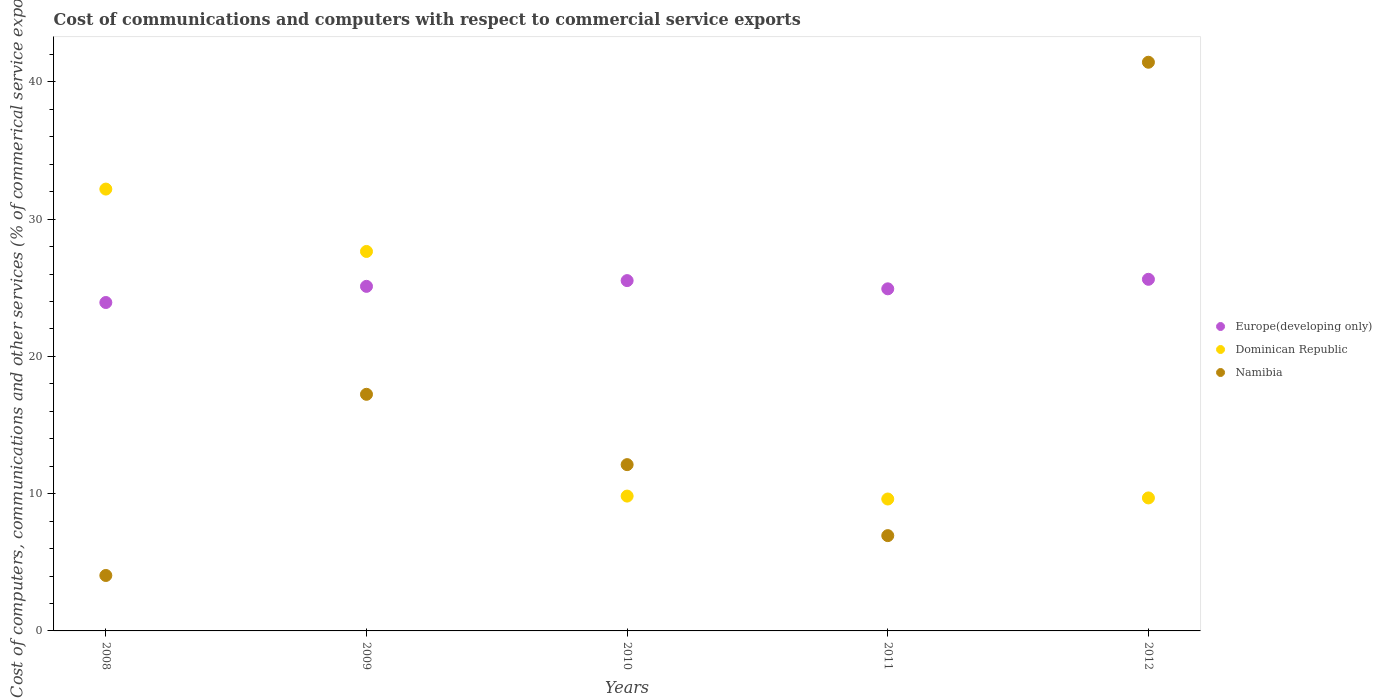Is the number of dotlines equal to the number of legend labels?
Your response must be concise. Yes. What is the cost of communications and computers in Dominican Republic in 2010?
Offer a terse response. 9.82. Across all years, what is the maximum cost of communications and computers in Europe(developing only)?
Your answer should be compact. 25.62. Across all years, what is the minimum cost of communications and computers in Namibia?
Give a very brief answer. 4.04. In which year was the cost of communications and computers in Europe(developing only) minimum?
Your answer should be very brief. 2008. What is the total cost of communications and computers in Dominican Republic in the graph?
Offer a very short reply. 88.97. What is the difference between the cost of communications and computers in Europe(developing only) in 2009 and that in 2010?
Your response must be concise. -0.42. What is the difference between the cost of communications and computers in Europe(developing only) in 2010 and the cost of communications and computers in Namibia in 2009?
Make the answer very short. 8.28. What is the average cost of communications and computers in Namibia per year?
Your answer should be very brief. 16.35. In the year 2011, what is the difference between the cost of communications and computers in Europe(developing only) and cost of communications and computers in Namibia?
Provide a short and direct response. 17.98. What is the ratio of the cost of communications and computers in Dominican Republic in 2009 to that in 2010?
Your response must be concise. 2.81. What is the difference between the highest and the second highest cost of communications and computers in Europe(developing only)?
Your answer should be compact. 0.1. What is the difference between the highest and the lowest cost of communications and computers in Europe(developing only)?
Your answer should be compact. 1.69. In how many years, is the cost of communications and computers in Dominican Republic greater than the average cost of communications and computers in Dominican Republic taken over all years?
Offer a very short reply. 2. Is the sum of the cost of communications and computers in Europe(developing only) in 2008 and 2011 greater than the maximum cost of communications and computers in Dominican Republic across all years?
Ensure brevity in your answer.  Yes. Is it the case that in every year, the sum of the cost of communications and computers in Dominican Republic and cost of communications and computers in Europe(developing only)  is greater than the cost of communications and computers in Namibia?
Your response must be concise. No. Is the cost of communications and computers in Dominican Republic strictly greater than the cost of communications and computers in Europe(developing only) over the years?
Offer a terse response. No. Is the cost of communications and computers in Europe(developing only) strictly less than the cost of communications and computers in Dominican Republic over the years?
Keep it short and to the point. No. How many years are there in the graph?
Give a very brief answer. 5. Are the values on the major ticks of Y-axis written in scientific E-notation?
Provide a short and direct response. No. Does the graph contain grids?
Provide a short and direct response. No. How many legend labels are there?
Your answer should be very brief. 3. What is the title of the graph?
Provide a short and direct response. Cost of communications and computers with respect to commercial service exports. Does "French Polynesia" appear as one of the legend labels in the graph?
Offer a very short reply. No. What is the label or title of the X-axis?
Make the answer very short. Years. What is the label or title of the Y-axis?
Provide a short and direct response. Cost of computers, communications and other services (% of commerical service exports). What is the Cost of computers, communications and other services (% of commerical service exports) in Europe(developing only) in 2008?
Your answer should be compact. 23.93. What is the Cost of computers, communications and other services (% of commerical service exports) in Dominican Republic in 2008?
Ensure brevity in your answer.  32.19. What is the Cost of computers, communications and other services (% of commerical service exports) of Namibia in 2008?
Provide a succinct answer. 4.04. What is the Cost of computers, communications and other services (% of commerical service exports) in Europe(developing only) in 2009?
Provide a short and direct response. 25.11. What is the Cost of computers, communications and other services (% of commerical service exports) of Dominican Republic in 2009?
Your answer should be compact. 27.65. What is the Cost of computers, communications and other services (% of commerical service exports) of Namibia in 2009?
Your response must be concise. 17.24. What is the Cost of computers, communications and other services (% of commerical service exports) in Europe(developing only) in 2010?
Your answer should be compact. 25.52. What is the Cost of computers, communications and other services (% of commerical service exports) of Dominican Republic in 2010?
Offer a very short reply. 9.82. What is the Cost of computers, communications and other services (% of commerical service exports) of Namibia in 2010?
Provide a succinct answer. 12.12. What is the Cost of computers, communications and other services (% of commerical service exports) in Europe(developing only) in 2011?
Your response must be concise. 24.93. What is the Cost of computers, communications and other services (% of commerical service exports) in Dominican Republic in 2011?
Provide a succinct answer. 9.61. What is the Cost of computers, communications and other services (% of commerical service exports) of Namibia in 2011?
Your answer should be compact. 6.94. What is the Cost of computers, communications and other services (% of commerical service exports) in Europe(developing only) in 2012?
Ensure brevity in your answer.  25.62. What is the Cost of computers, communications and other services (% of commerical service exports) in Dominican Republic in 2012?
Ensure brevity in your answer.  9.69. What is the Cost of computers, communications and other services (% of commerical service exports) of Namibia in 2012?
Offer a terse response. 41.43. Across all years, what is the maximum Cost of computers, communications and other services (% of commerical service exports) in Europe(developing only)?
Offer a very short reply. 25.62. Across all years, what is the maximum Cost of computers, communications and other services (% of commerical service exports) of Dominican Republic?
Ensure brevity in your answer.  32.19. Across all years, what is the maximum Cost of computers, communications and other services (% of commerical service exports) of Namibia?
Make the answer very short. 41.43. Across all years, what is the minimum Cost of computers, communications and other services (% of commerical service exports) of Europe(developing only)?
Make the answer very short. 23.93. Across all years, what is the minimum Cost of computers, communications and other services (% of commerical service exports) in Dominican Republic?
Offer a very short reply. 9.61. Across all years, what is the minimum Cost of computers, communications and other services (% of commerical service exports) of Namibia?
Ensure brevity in your answer.  4.04. What is the total Cost of computers, communications and other services (% of commerical service exports) of Europe(developing only) in the graph?
Provide a short and direct response. 125.1. What is the total Cost of computers, communications and other services (% of commerical service exports) in Dominican Republic in the graph?
Offer a very short reply. 88.97. What is the total Cost of computers, communications and other services (% of commerical service exports) in Namibia in the graph?
Ensure brevity in your answer.  81.77. What is the difference between the Cost of computers, communications and other services (% of commerical service exports) of Europe(developing only) in 2008 and that in 2009?
Your response must be concise. -1.18. What is the difference between the Cost of computers, communications and other services (% of commerical service exports) in Dominican Republic in 2008 and that in 2009?
Keep it short and to the point. 4.54. What is the difference between the Cost of computers, communications and other services (% of commerical service exports) of Namibia in 2008 and that in 2009?
Offer a very short reply. -13.2. What is the difference between the Cost of computers, communications and other services (% of commerical service exports) of Europe(developing only) in 2008 and that in 2010?
Keep it short and to the point. -1.6. What is the difference between the Cost of computers, communications and other services (% of commerical service exports) in Dominican Republic in 2008 and that in 2010?
Offer a very short reply. 22.37. What is the difference between the Cost of computers, communications and other services (% of commerical service exports) of Namibia in 2008 and that in 2010?
Your response must be concise. -8.08. What is the difference between the Cost of computers, communications and other services (% of commerical service exports) in Europe(developing only) in 2008 and that in 2011?
Ensure brevity in your answer.  -1. What is the difference between the Cost of computers, communications and other services (% of commerical service exports) of Dominican Republic in 2008 and that in 2011?
Keep it short and to the point. 22.58. What is the difference between the Cost of computers, communications and other services (% of commerical service exports) in Namibia in 2008 and that in 2011?
Your answer should be very brief. -2.9. What is the difference between the Cost of computers, communications and other services (% of commerical service exports) in Europe(developing only) in 2008 and that in 2012?
Your response must be concise. -1.69. What is the difference between the Cost of computers, communications and other services (% of commerical service exports) of Dominican Republic in 2008 and that in 2012?
Provide a succinct answer. 22.5. What is the difference between the Cost of computers, communications and other services (% of commerical service exports) in Namibia in 2008 and that in 2012?
Ensure brevity in your answer.  -37.4. What is the difference between the Cost of computers, communications and other services (% of commerical service exports) in Europe(developing only) in 2009 and that in 2010?
Provide a succinct answer. -0.42. What is the difference between the Cost of computers, communications and other services (% of commerical service exports) of Dominican Republic in 2009 and that in 2010?
Your response must be concise. 17.82. What is the difference between the Cost of computers, communications and other services (% of commerical service exports) in Namibia in 2009 and that in 2010?
Keep it short and to the point. 5.12. What is the difference between the Cost of computers, communications and other services (% of commerical service exports) of Europe(developing only) in 2009 and that in 2011?
Offer a terse response. 0.18. What is the difference between the Cost of computers, communications and other services (% of commerical service exports) in Dominican Republic in 2009 and that in 2011?
Provide a succinct answer. 18.04. What is the difference between the Cost of computers, communications and other services (% of commerical service exports) in Namibia in 2009 and that in 2011?
Make the answer very short. 10.3. What is the difference between the Cost of computers, communications and other services (% of commerical service exports) in Europe(developing only) in 2009 and that in 2012?
Your answer should be very brief. -0.51. What is the difference between the Cost of computers, communications and other services (% of commerical service exports) in Dominican Republic in 2009 and that in 2012?
Provide a succinct answer. 17.96. What is the difference between the Cost of computers, communications and other services (% of commerical service exports) in Namibia in 2009 and that in 2012?
Your response must be concise. -24.19. What is the difference between the Cost of computers, communications and other services (% of commerical service exports) in Europe(developing only) in 2010 and that in 2011?
Your response must be concise. 0.6. What is the difference between the Cost of computers, communications and other services (% of commerical service exports) in Dominican Republic in 2010 and that in 2011?
Give a very brief answer. 0.21. What is the difference between the Cost of computers, communications and other services (% of commerical service exports) in Namibia in 2010 and that in 2011?
Provide a short and direct response. 5.17. What is the difference between the Cost of computers, communications and other services (% of commerical service exports) of Europe(developing only) in 2010 and that in 2012?
Your answer should be very brief. -0.1. What is the difference between the Cost of computers, communications and other services (% of commerical service exports) in Dominican Republic in 2010 and that in 2012?
Your answer should be very brief. 0.13. What is the difference between the Cost of computers, communications and other services (% of commerical service exports) in Namibia in 2010 and that in 2012?
Make the answer very short. -29.32. What is the difference between the Cost of computers, communications and other services (% of commerical service exports) of Europe(developing only) in 2011 and that in 2012?
Keep it short and to the point. -0.69. What is the difference between the Cost of computers, communications and other services (% of commerical service exports) of Dominican Republic in 2011 and that in 2012?
Provide a succinct answer. -0.08. What is the difference between the Cost of computers, communications and other services (% of commerical service exports) of Namibia in 2011 and that in 2012?
Offer a very short reply. -34.49. What is the difference between the Cost of computers, communications and other services (% of commerical service exports) in Europe(developing only) in 2008 and the Cost of computers, communications and other services (% of commerical service exports) in Dominican Republic in 2009?
Give a very brief answer. -3.72. What is the difference between the Cost of computers, communications and other services (% of commerical service exports) of Europe(developing only) in 2008 and the Cost of computers, communications and other services (% of commerical service exports) of Namibia in 2009?
Keep it short and to the point. 6.69. What is the difference between the Cost of computers, communications and other services (% of commerical service exports) of Dominican Republic in 2008 and the Cost of computers, communications and other services (% of commerical service exports) of Namibia in 2009?
Provide a short and direct response. 14.95. What is the difference between the Cost of computers, communications and other services (% of commerical service exports) of Europe(developing only) in 2008 and the Cost of computers, communications and other services (% of commerical service exports) of Dominican Republic in 2010?
Your response must be concise. 14.1. What is the difference between the Cost of computers, communications and other services (% of commerical service exports) in Europe(developing only) in 2008 and the Cost of computers, communications and other services (% of commerical service exports) in Namibia in 2010?
Provide a succinct answer. 11.81. What is the difference between the Cost of computers, communications and other services (% of commerical service exports) of Dominican Republic in 2008 and the Cost of computers, communications and other services (% of commerical service exports) of Namibia in 2010?
Offer a terse response. 20.08. What is the difference between the Cost of computers, communications and other services (% of commerical service exports) in Europe(developing only) in 2008 and the Cost of computers, communications and other services (% of commerical service exports) in Dominican Republic in 2011?
Your response must be concise. 14.32. What is the difference between the Cost of computers, communications and other services (% of commerical service exports) in Europe(developing only) in 2008 and the Cost of computers, communications and other services (% of commerical service exports) in Namibia in 2011?
Your answer should be very brief. 16.99. What is the difference between the Cost of computers, communications and other services (% of commerical service exports) of Dominican Republic in 2008 and the Cost of computers, communications and other services (% of commerical service exports) of Namibia in 2011?
Provide a succinct answer. 25.25. What is the difference between the Cost of computers, communications and other services (% of commerical service exports) in Europe(developing only) in 2008 and the Cost of computers, communications and other services (% of commerical service exports) in Dominican Republic in 2012?
Your response must be concise. 14.24. What is the difference between the Cost of computers, communications and other services (% of commerical service exports) in Europe(developing only) in 2008 and the Cost of computers, communications and other services (% of commerical service exports) in Namibia in 2012?
Give a very brief answer. -17.51. What is the difference between the Cost of computers, communications and other services (% of commerical service exports) in Dominican Republic in 2008 and the Cost of computers, communications and other services (% of commerical service exports) in Namibia in 2012?
Provide a short and direct response. -9.24. What is the difference between the Cost of computers, communications and other services (% of commerical service exports) in Europe(developing only) in 2009 and the Cost of computers, communications and other services (% of commerical service exports) in Dominican Republic in 2010?
Keep it short and to the point. 15.28. What is the difference between the Cost of computers, communications and other services (% of commerical service exports) in Europe(developing only) in 2009 and the Cost of computers, communications and other services (% of commerical service exports) in Namibia in 2010?
Your answer should be compact. 12.99. What is the difference between the Cost of computers, communications and other services (% of commerical service exports) of Dominican Republic in 2009 and the Cost of computers, communications and other services (% of commerical service exports) of Namibia in 2010?
Provide a short and direct response. 15.53. What is the difference between the Cost of computers, communications and other services (% of commerical service exports) in Europe(developing only) in 2009 and the Cost of computers, communications and other services (% of commerical service exports) in Dominican Republic in 2011?
Keep it short and to the point. 15.49. What is the difference between the Cost of computers, communications and other services (% of commerical service exports) in Europe(developing only) in 2009 and the Cost of computers, communications and other services (% of commerical service exports) in Namibia in 2011?
Offer a terse response. 18.16. What is the difference between the Cost of computers, communications and other services (% of commerical service exports) of Dominican Republic in 2009 and the Cost of computers, communications and other services (% of commerical service exports) of Namibia in 2011?
Your answer should be compact. 20.7. What is the difference between the Cost of computers, communications and other services (% of commerical service exports) of Europe(developing only) in 2009 and the Cost of computers, communications and other services (% of commerical service exports) of Dominican Republic in 2012?
Make the answer very short. 15.42. What is the difference between the Cost of computers, communications and other services (% of commerical service exports) of Europe(developing only) in 2009 and the Cost of computers, communications and other services (% of commerical service exports) of Namibia in 2012?
Offer a very short reply. -16.33. What is the difference between the Cost of computers, communications and other services (% of commerical service exports) of Dominican Republic in 2009 and the Cost of computers, communications and other services (% of commerical service exports) of Namibia in 2012?
Ensure brevity in your answer.  -13.79. What is the difference between the Cost of computers, communications and other services (% of commerical service exports) in Europe(developing only) in 2010 and the Cost of computers, communications and other services (% of commerical service exports) in Dominican Republic in 2011?
Offer a terse response. 15.91. What is the difference between the Cost of computers, communications and other services (% of commerical service exports) of Europe(developing only) in 2010 and the Cost of computers, communications and other services (% of commerical service exports) of Namibia in 2011?
Offer a terse response. 18.58. What is the difference between the Cost of computers, communications and other services (% of commerical service exports) in Dominican Republic in 2010 and the Cost of computers, communications and other services (% of commerical service exports) in Namibia in 2011?
Offer a terse response. 2.88. What is the difference between the Cost of computers, communications and other services (% of commerical service exports) of Europe(developing only) in 2010 and the Cost of computers, communications and other services (% of commerical service exports) of Dominican Republic in 2012?
Ensure brevity in your answer.  15.83. What is the difference between the Cost of computers, communications and other services (% of commerical service exports) in Europe(developing only) in 2010 and the Cost of computers, communications and other services (% of commerical service exports) in Namibia in 2012?
Your answer should be compact. -15.91. What is the difference between the Cost of computers, communications and other services (% of commerical service exports) of Dominican Republic in 2010 and the Cost of computers, communications and other services (% of commerical service exports) of Namibia in 2012?
Offer a very short reply. -31.61. What is the difference between the Cost of computers, communications and other services (% of commerical service exports) of Europe(developing only) in 2011 and the Cost of computers, communications and other services (% of commerical service exports) of Dominican Republic in 2012?
Offer a very short reply. 15.23. What is the difference between the Cost of computers, communications and other services (% of commerical service exports) in Europe(developing only) in 2011 and the Cost of computers, communications and other services (% of commerical service exports) in Namibia in 2012?
Provide a succinct answer. -16.51. What is the difference between the Cost of computers, communications and other services (% of commerical service exports) in Dominican Republic in 2011 and the Cost of computers, communications and other services (% of commerical service exports) in Namibia in 2012?
Keep it short and to the point. -31.82. What is the average Cost of computers, communications and other services (% of commerical service exports) in Europe(developing only) per year?
Make the answer very short. 25.02. What is the average Cost of computers, communications and other services (% of commerical service exports) of Dominican Republic per year?
Offer a very short reply. 17.79. What is the average Cost of computers, communications and other services (% of commerical service exports) in Namibia per year?
Offer a very short reply. 16.35. In the year 2008, what is the difference between the Cost of computers, communications and other services (% of commerical service exports) in Europe(developing only) and Cost of computers, communications and other services (% of commerical service exports) in Dominican Republic?
Provide a short and direct response. -8.26. In the year 2008, what is the difference between the Cost of computers, communications and other services (% of commerical service exports) of Europe(developing only) and Cost of computers, communications and other services (% of commerical service exports) of Namibia?
Ensure brevity in your answer.  19.89. In the year 2008, what is the difference between the Cost of computers, communications and other services (% of commerical service exports) in Dominican Republic and Cost of computers, communications and other services (% of commerical service exports) in Namibia?
Provide a short and direct response. 28.15. In the year 2009, what is the difference between the Cost of computers, communications and other services (% of commerical service exports) in Europe(developing only) and Cost of computers, communications and other services (% of commerical service exports) in Dominican Republic?
Provide a short and direct response. -2.54. In the year 2009, what is the difference between the Cost of computers, communications and other services (% of commerical service exports) of Europe(developing only) and Cost of computers, communications and other services (% of commerical service exports) of Namibia?
Your answer should be compact. 7.87. In the year 2009, what is the difference between the Cost of computers, communications and other services (% of commerical service exports) of Dominican Republic and Cost of computers, communications and other services (% of commerical service exports) of Namibia?
Your response must be concise. 10.41. In the year 2010, what is the difference between the Cost of computers, communications and other services (% of commerical service exports) in Europe(developing only) and Cost of computers, communications and other services (% of commerical service exports) in Dominican Republic?
Give a very brief answer. 15.7. In the year 2010, what is the difference between the Cost of computers, communications and other services (% of commerical service exports) in Europe(developing only) and Cost of computers, communications and other services (% of commerical service exports) in Namibia?
Give a very brief answer. 13.41. In the year 2010, what is the difference between the Cost of computers, communications and other services (% of commerical service exports) of Dominican Republic and Cost of computers, communications and other services (% of commerical service exports) of Namibia?
Your response must be concise. -2.29. In the year 2011, what is the difference between the Cost of computers, communications and other services (% of commerical service exports) of Europe(developing only) and Cost of computers, communications and other services (% of commerical service exports) of Dominican Republic?
Your response must be concise. 15.31. In the year 2011, what is the difference between the Cost of computers, communications and other services (% of commerical service exports) of Europe(developing only) and Cost of computers, communications and other services (% of commerical service exports) of Namibia?
Make the answer very short. 17.98. In the year 2011, what is the difference between the Cost of computers, communications and other services (% of commerical service exports) of Dominican Republic and Cost of computers, communications and other services (% of commerical service exports) of Namibia?
Your answer should be very brief. 2.67. In the year 2012, what is the difference between the Cost of computers, communications and other services (% of commerical service exports) of Europe(developing only) and Cost of computers, communications and other services (% of commerical service exports) of Dominican Republic?
Provide a short and direct response. 15.93. In the year 2012, what is the difference between the Cost of computers, communications and other services (% of commerical service exports) in Europe(developing only) and Cost of computers, communications and other services (% of commerical service exports) in Namibia?
Provide a succinct answer. -15.82. In the year 2012, what is the difference between the Cost of computers, communications and other services (% of commerical service exports) of Dominican Republic and Cost of computers, communications and other services (% of commerical service exports) of Namibia?
Provide a short and direct response. -31.74. What is the ratio of the Cost of computers, communications and other services (% of commerical service exports) in Europe(developing only) in 2008 to that in 2009?
Offer a terse response. 0.95. What is the ratio of the Cost of computers, communications and other services (% of commerical service exports) in Dominican Republic in 2008 to that in 2009?
Keep it short and to the point. 1.16. What is the ratio of the Cost of computers, communications and other services (% of commerical service exports) of Namibia in 2008 to that in 2009?
Ensure brevity in your answer.  0.23. What is the ratio of the Cost of computers, communications and other services (% of commerical service exports) in Europe(developing only) in 2008 to that in 2010?
Make the answer very short. 0.94. What is the ratio of the Cost of computers, communications and other services (% of commerical service exports) of Dominican Republic in 2008 to that in 2010?
Provide a short and direct response. 3.28. What is the ratio of the Cost of computers, communications and other services (% of commerical service exports) in Namibia in 2008 to that in 2010?
Keep it short and to the point. 0.33. What is the ratio of the Cost of computers, communications and other services (% of commerical service exports) in Dominican Republic in 2008 to that in 2011?
Your answer should be compact. 3.35. What is the ratio of the Cost of computers, communications and other services (% of commerical service exports) of Namibia in 2008 to that in 2011?
Your answer should be compact. 0.58. What is the ratio of the Cost of computers, communications and other services (% of commerical service exports) in Europe(developing only) in 2008 to that in 2012?
Provide a succinct answer. 0.93. What is the ratio of the Cost of computers, communications and other services (% of commerical service exports) in Dominican Republic in 2008 to that in 2012?
Your answer should be compact. 3.32. What is the ratio of the Cost of computers, communications and other services (% of commerical service exports) of Namibia in 2008 to that in 2012?
Offer a terse response. 0.1. What is the ratio of the Cost of computers, communications and other services (% of commerical service exports) in Europe(developing only) in 2009 to that in 2010?
Offer a terse response. 0.98. What is the ratio of the Cost of computers, communications and other services (% of commerical service exports) in Dominican Republic in 2009 to that in 2010?
Your answer should be compact. 2.81. What is the ratio of the Cost of computers, communications and other services (% of commerical service exports) in Namibia in 2009 to that in 2010?
Keep it short and to the point. 1.42. What is the ratio of the Cost of computers, communications and other services (% of commerical service exports) in Dominican Republic in 2009 to that in 2011?
Offer a terse response. 2.88. What is the ratio of the Cost of computers, communications and other services (% of commerical service exports) of Namibia in 2009 to that in 2011?
Keep it short and to the point. 2.48. What is the ratio of the Cost of computers, communications and other services (% of commerical service exports) in Dominican Republic in 2009 to that in 2012?
Offer a very short reply. 2.85. What is the ratio of the Cost of computers, communications and other services (% of commerical service exports) in Namibia in 2009 to that in 2012?
Ensure brevity in your answer.  0.42. What is the ratio of the Cost of computers, communications and other services (% of commerical service exports) in Dominican Republic in 2010 to that in 2011?
Make the answer very short. 1.02. What is the ratio of the Cost of computers, communications and other services (% of commerical service exports) of Namibia in 2010 to that in 2011?
Make the answer very short. 1.75. What is the ratio of the Cost of computers, communications and other services (% of commerical service exports) of Europe(developing only) in 2010 to that in 2012?
Your response must be concise. 1. What is the ratio of the Cost of computers, communications and other services (% of commerical service exports) in Dominican Republic in 2010 to that in 2012?
Make the answer very short. 1.01. What is the ratio of the Cost of computers, communications and other services (% of commerical service exports) in Namibia in 2010 to that in 2012?
Offer a very short reply. 0.29. What is the ratio of the Cost of computers, communications and other services (% of commerical service exports) in Europe(developing only) in 2011 to that in 2012?
Give a very brief answer. 0.97. What is the ratio of the Cost of computers, communications and other services (% of commerical service exports) in Namibia in 2011 to that in 2012?
Give a very brief answer. 0.17. What is the difference between the highest and the second highest Cost of computers, communications and other services (% of commerical service exports) of Europe(developing only)?
Your response must be concise. 0.1. What is the difference between the highest and the second highest Cost of computers, communications and other services (% of commerical service exports) of Dominican Republic?
Make the answer very short. 4.54. What is the difference between the highest and the second highest Cost of computers, communications and other services (% of commerical service exports) in Namibia?
Your answer should be very brief. 24.19. What is the difference between the highest and the lowest Cost of computers, communications and other services (% of commerical service exports) of Europe(developing only)?
Make the answer very short. 1.69. What is the difference between the highest and the lowest Cost of computers, communications and other services (% of commerical service exports) in Dominican Republic?
Ensure brevity in your answer.  22.58. What is the difference between the highest and the lowest Cost of computers, communications and other services (% of commerical service exports) in Namibia?
Your response must be concise. 37.4. 